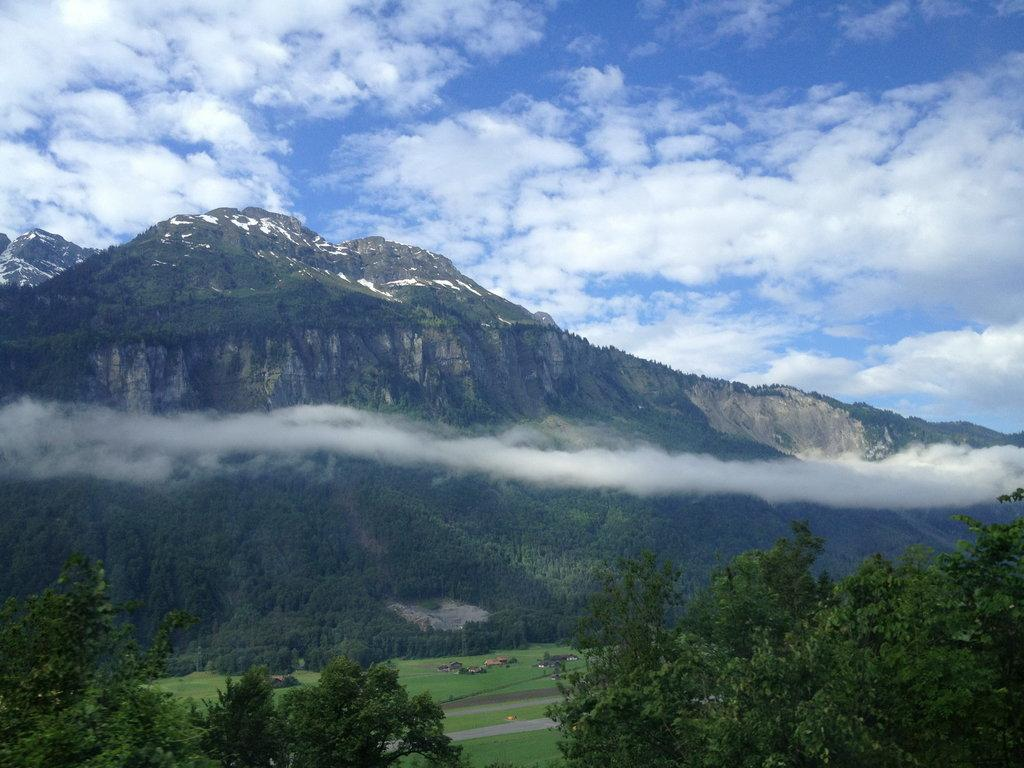What type of natural landform is present in the image? There is a mountain in the image. What is the condition of the sky in the image? The sky is cloudy in the image. What type of vegetation is visible in the image? There is grass visible in the image. Are there any other plants besides grass in the image? Yes, there are trees in the image. Can you tell me how many mint leaves are growing on the mountain in the image? There is no mention of mint leaves in the image; the image only features a mountain, a cloudy sky, grass, and trees. How many cats can be seen climbing the mountain in the image? There are no cats present in the image; the image only features a mountain, a cloudy sky, grass, and trees. 